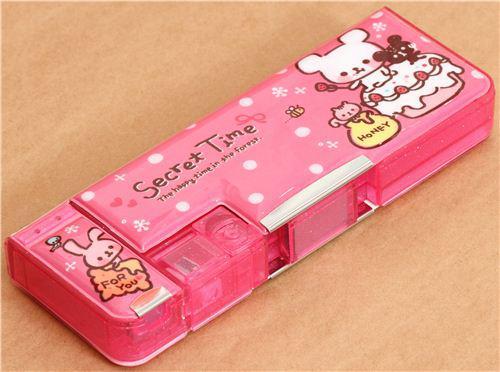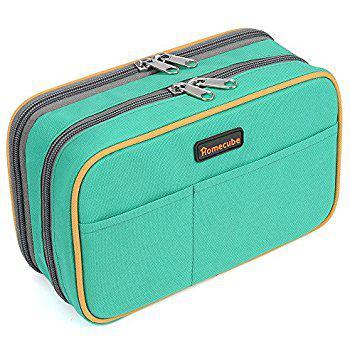The first image is the image on the left, the second image is the image on the right. For the images displayed, is the sentence "the right image has a pencil pouch with 2 front pockets and two zippers on top" factually correct? Answer yes or no. Yes. The first image is the image on the left, the second image is the image on the right. Evaluate the accuracy of this statement regarding the images: "The image on the right has a double zipper.". Is it true? Answer yes or no. Yes. 